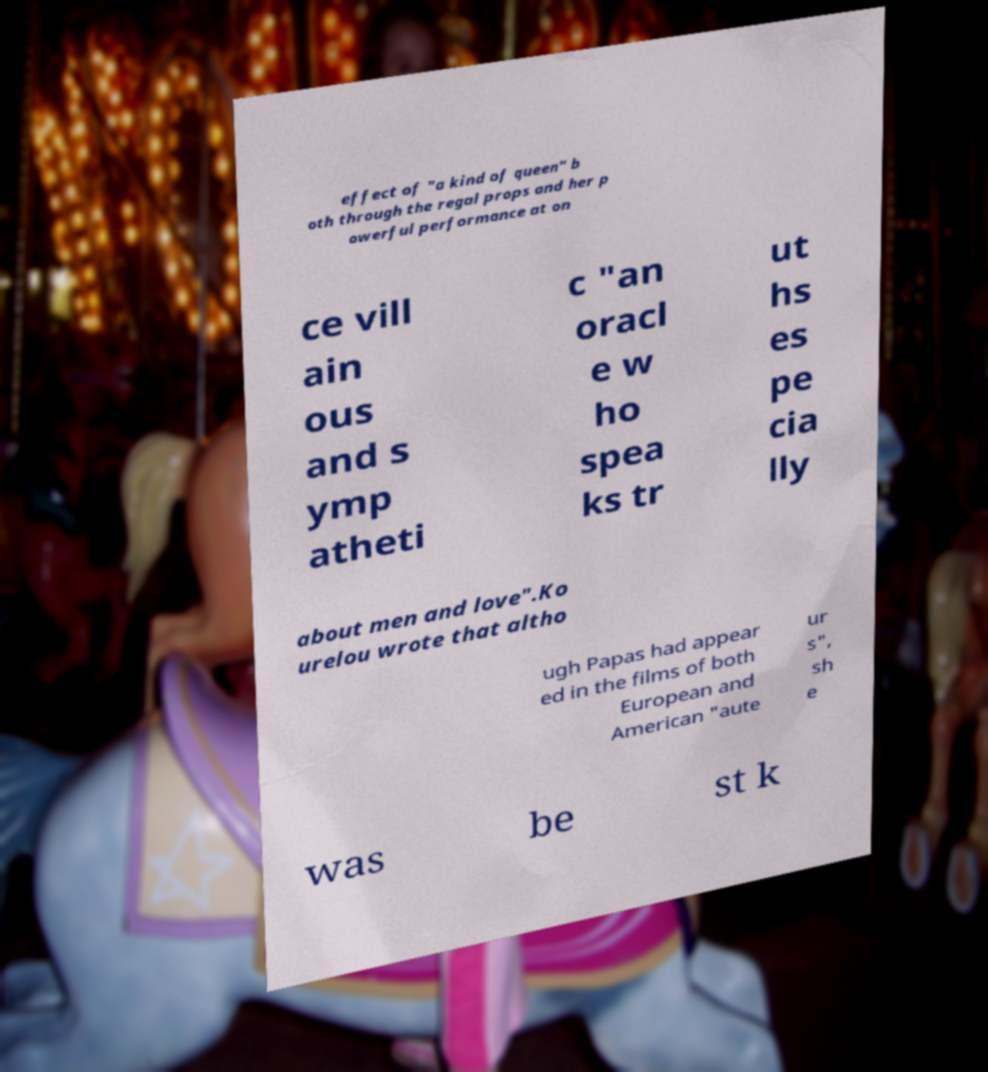There's text embedded in this image that I need extracted. Can you transcribe it verbatim? effect of "a kind of queen" b oth through the regal props and her p owerful performance at on ce vill ain ous and s ymp atheti c "an oracl e w ho spea ks tr ut hs es pe cia lly about men and love".Ko urelou wrote that altho ugh Papas had appear ed in the films of both European and American "aute ur s", sh e was be st k 